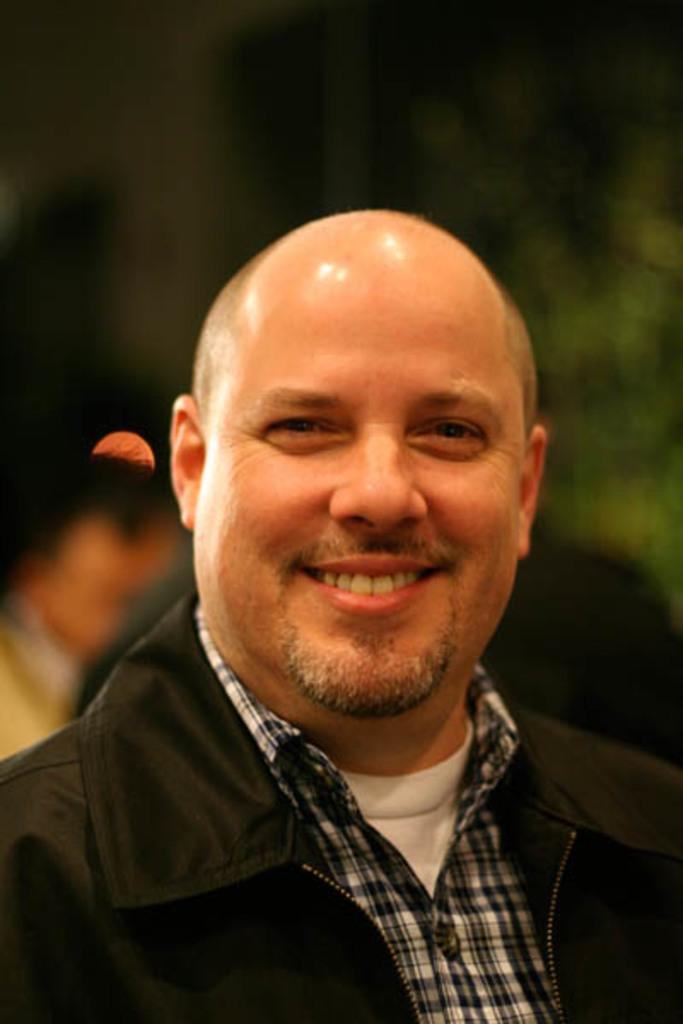What is the main subject of the image? There is a man in the image. What is the man's facial expression? The man is smiling. Can you describe the background of the image? The background of the image is blurry. What type of key is the man holding in the image? There is no key present in the image; it only features a man who is smiling. 